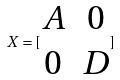Convert formula to latex. <formula><loc_0><loc_0><loc_500><loc_500>X = [ \begin{matrix} A & 0 \\ 0 & D \end{matrix} ]</formula> 